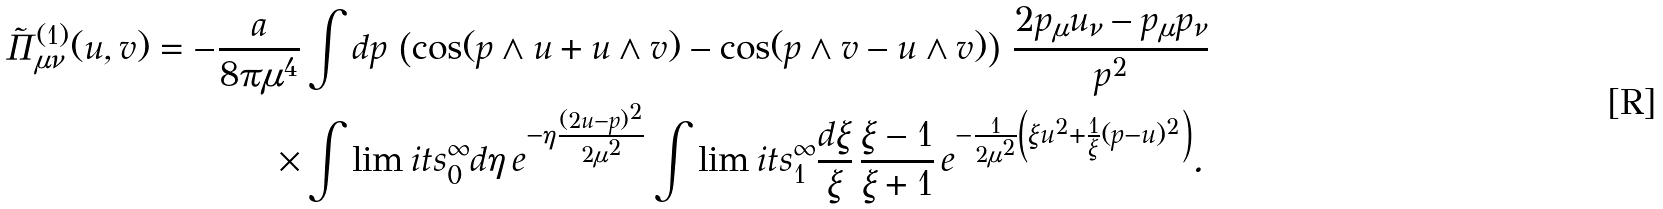<formula> <loc_0><loc_0><loc_500><loc_500>\tilde { \Pi } _ { \mu \nu } ^ { ( 1 ) } ( u , v ) = - \frac { a } { 8 \pi \mu ^ { 4 } } & \int d p \, \left ( \cos ( p \wedge u + u \wedge v ) - \cos ( p \wedge v - u \wedge v ) \right ) \, \frac { 2 p _ { \mu } u _ { \nu } - p _ { \mu } p _ { \nu } } { p ^ { 2 } } \\ \times & \int \lim i t s ^ { \infty } _ { 0 } d \eta \, e ^ { - \eta \frac { ( 2 u - p ) ^ { 2 } } { 2 \mu ^ { 2 } } } \int \lim i t s ^ { \infty } _ { 1 } \frac { d \xi } { \xi } \, \frac { \xi - 1 } { \xi + 1 } \, e ^ { - \frac { 1 } { 2 \mu ^ { 2 } } \left ( \xi u ^ { 2 } + \frac { 1 } { \xi } ( p - u ) ^ { 2 } \right ) } .</formula> 